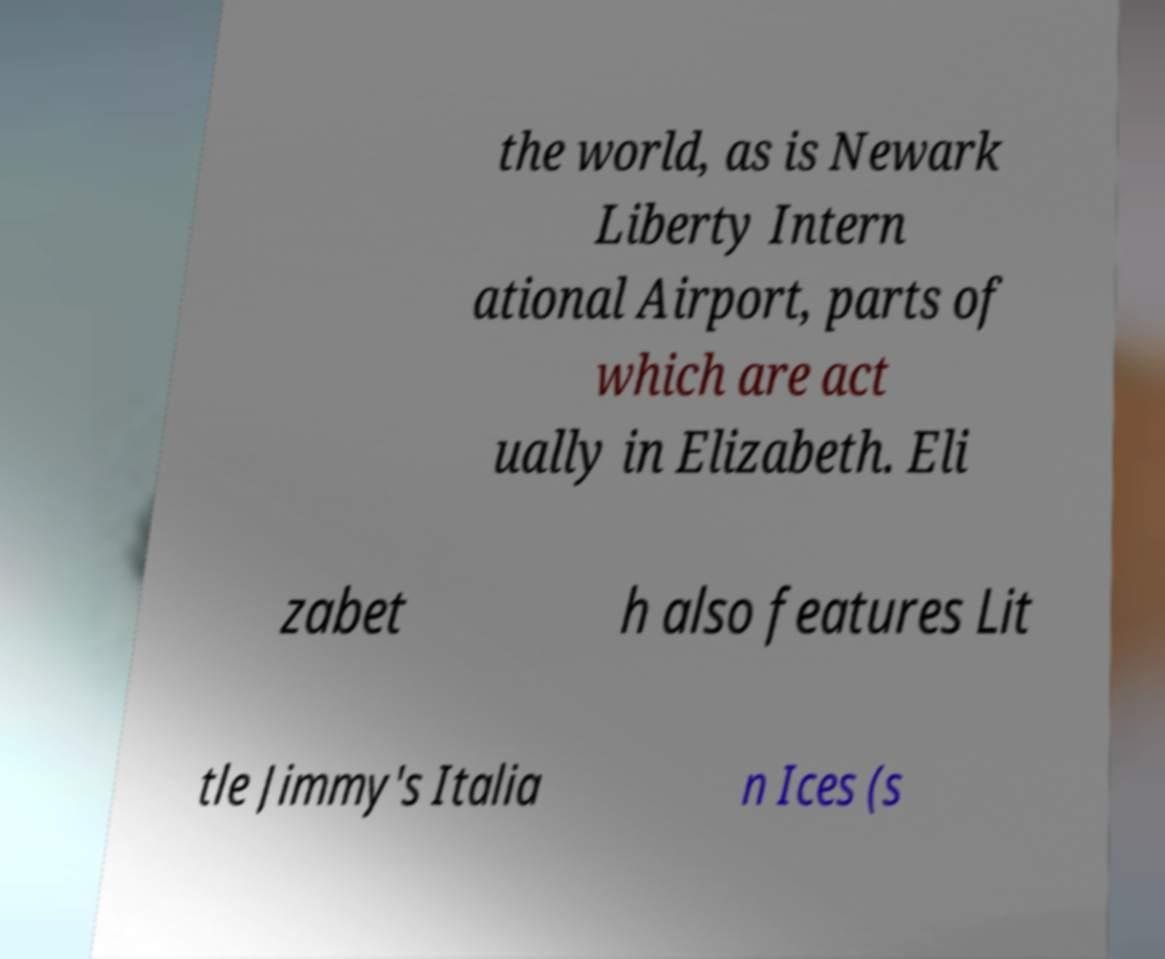Can you accurately transcribe the text from the provided image for me? the world, as is Newark Liberty Intern ational Airport, parts of which are act ually in Elizabeth. Eli zabet h also features Lit tle Jimmy's Italia n Ices (s 